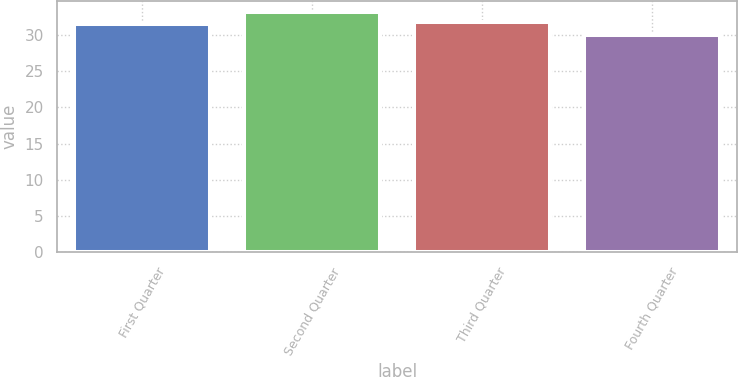<chart> <loc_0><loc_0><loc_500><loc_500><bar_chart><fcel>First Quarter<fcel>Second Quarter<fcel>Third Quarter<fcel>Fourth Quarter<nl><fcel>31.5<fcel>33.1<fcel>31.81<fcel>30.01<nl></chart> 